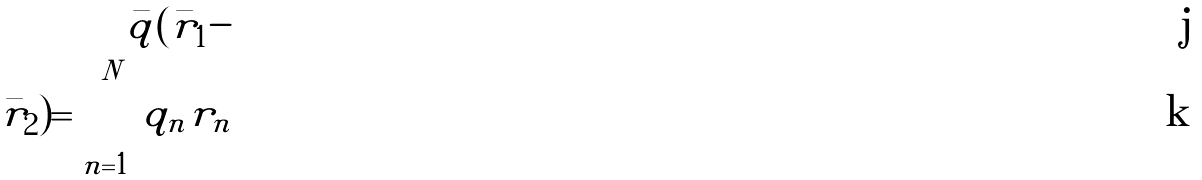Convert formula to latex. <formula><loc_0><loc_0><loc_500><loc_500>\bar { q } ( { \bar { r } _ { 1 } } - \\ \bar { r } _ { 2 } ) = \sum _ { n = 1 } ^ { N } q _ { n } r _ { n }</formula> 